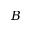<formula> <loc_0><loc_0><loc_500><loc_500>B</formula> 